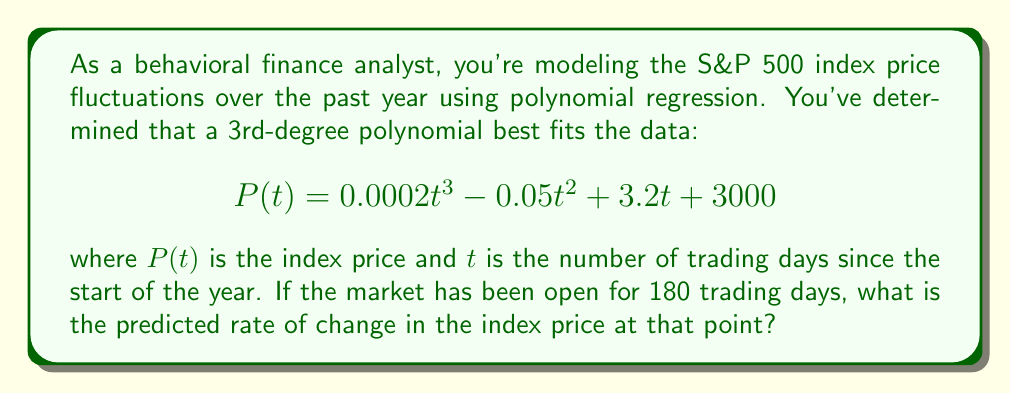Help me with this question. To find the rate of change in the index price at $t = 180$, we need to calculate the derivative of the polynomial function $P(t)$ and evaluate it at $t = 180$. Here's the step-by-step process:

1) First, let's find the derivative of $P(t)$:
   $$P(t) = 0.0002t^3 - 0.05t^2 + 3.2t + 3000$$
   $$P'(t) = 0.0006t^2 - 0.1t + 3.2$$

2) Now, we need to evaluate $P'(180)$:
   $$P'(180) = 0.0006(180)^2 - 0.1(180) + 3.2$$

3) Let's calculate each term:
   - $0.0006(180)^2 = 0.0006 * 32400 = 19.44$
   - $-0.1(180) = -18$
   - $3.2$ remains as is

4) Sum up the terms:
   $$P'(180) = 19.44 - 18 + 3.2 = 4.64$$

The rate of change is measured in price units per trading day. In this case, it's dollars per trading day for the S&P 500 index.
Answer: $4.64 